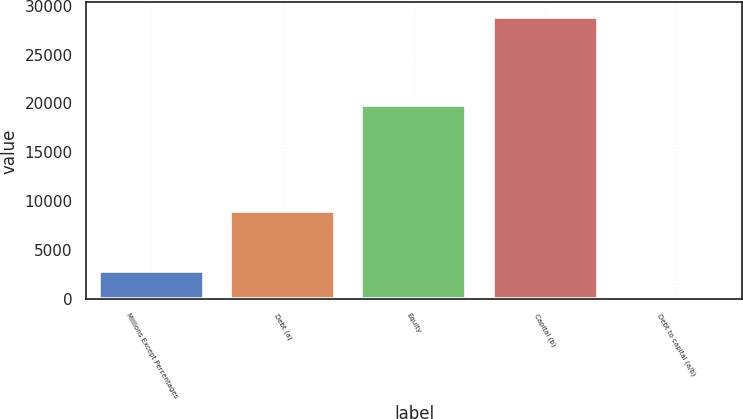Convert chart. <chart><loc_0><loc_0><loc_500><loc_500><bar_chart><fcel>Millions Except Percentages<fcel>Debt (a)<fcel>Equity<fcel>Capital (b)<fcel>Debt to capital (a/b)<nl><fcel>2915.48<fcel>8997<fcel>19877<fcel>28874<fcel>31.2<nl></chart> 